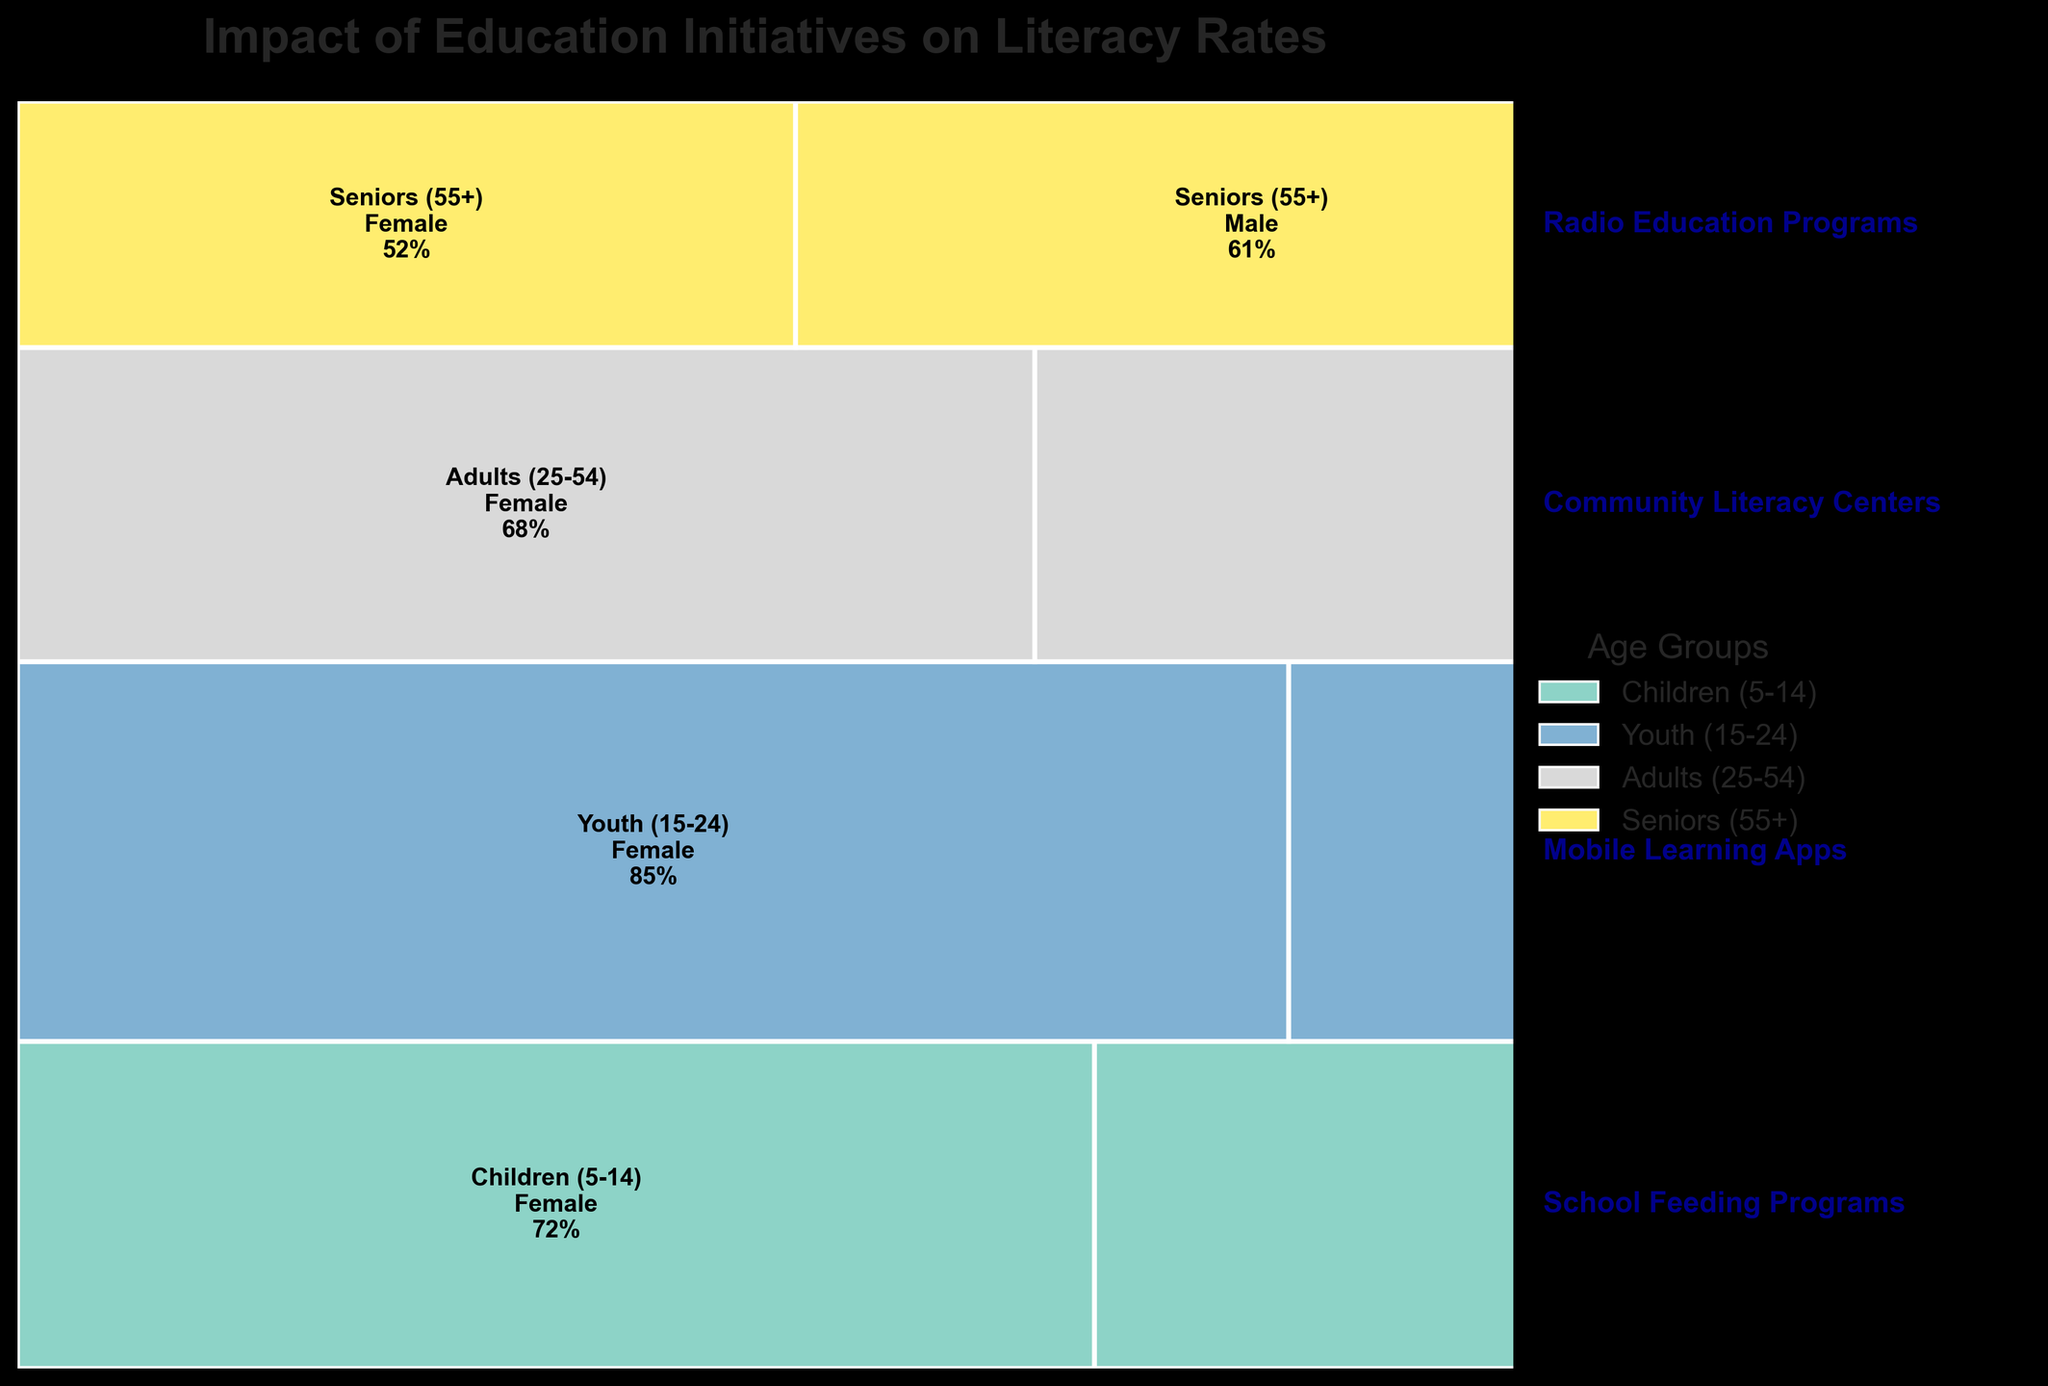What is the title of the plot? The title of the plot is displayed at the top in bold, which is a common feature in most plots. The title provides the overall description of what the plot represents.
Answer: Impact of Education Initiatives on Literacy Rates What has the highest literacy rate according to the plot? Examine the literacy rates shown within the plot for each age group and gender. Identify the highest percentage value among these data points.
Answer: Youth (15-24), Male at 89% Which education initiative is associated with the Youth (15-24) age group? Each age group is labeled with its corresponding education initiative on the right side of the plot. Locate the correct age group and read the label on the right.
Answer: Mobile Learning Apps How does literacy rate differ between males and females in the age group of Adults (25-54)? Identify the literacy rates for both males and females within the Adults (25-54) age group, then subtract the female rate from the male rate to find the difference.
Answer: 8% What is the total literacy rate of the Female gender across all age groups? Sum the literacy rates for the Female gender in each age group: 72% (Children) + 85% (Youth) + 68% (Adults) + 52% (Seniors).
Answer: 277% Which age group has the smallest difference in literacy rates between genders? Calculate the difference in literacy rates between males and females for each age group using simple subtraction, then identify the smallest difference.
Answer: Youth (15-24) with a 4% difference Between which age groups is the disparity in male literacy rates the largest? Compare the literacy rates of males across all age groups and find the largest difference between any two consecutive age groups.
Answer: Between Seniors (55+) and Youth (15-24) with a difference of 28% Are there any age groups where the gender disparity in literacy rates and the initiative names have the same first letter (e.g., F-for-Female and Feeding Program)? Examine each age group. Check whether the initiative names and gender disparity (defined as "Female" or "Male") for that age group start with the same letter.
Answer: Yes, School Feeding Programs and Female in Children (5-14) What is the average literacy rate for Seniors (55+) across genders? Add the literacy rates for Senior males and females and divide by 2. Calculation: (52% + 61%) / 2 = 56.5%
Answer: 56.5% Which education initiative is linked to the lowest overall literacy rates? Identify the initiative associated with the age group that has the lowest male and female literacy rates in comparison to other age groups.
Answer: Radio Education Programs 